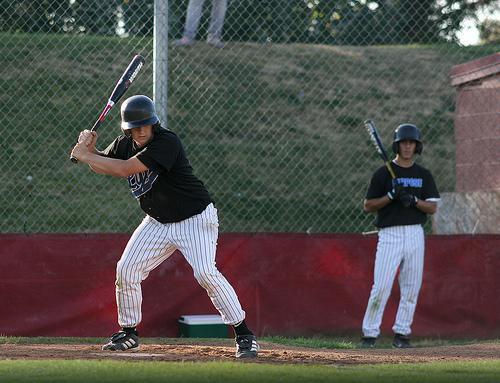How many people are there?
Give a very brief answer. 2. 